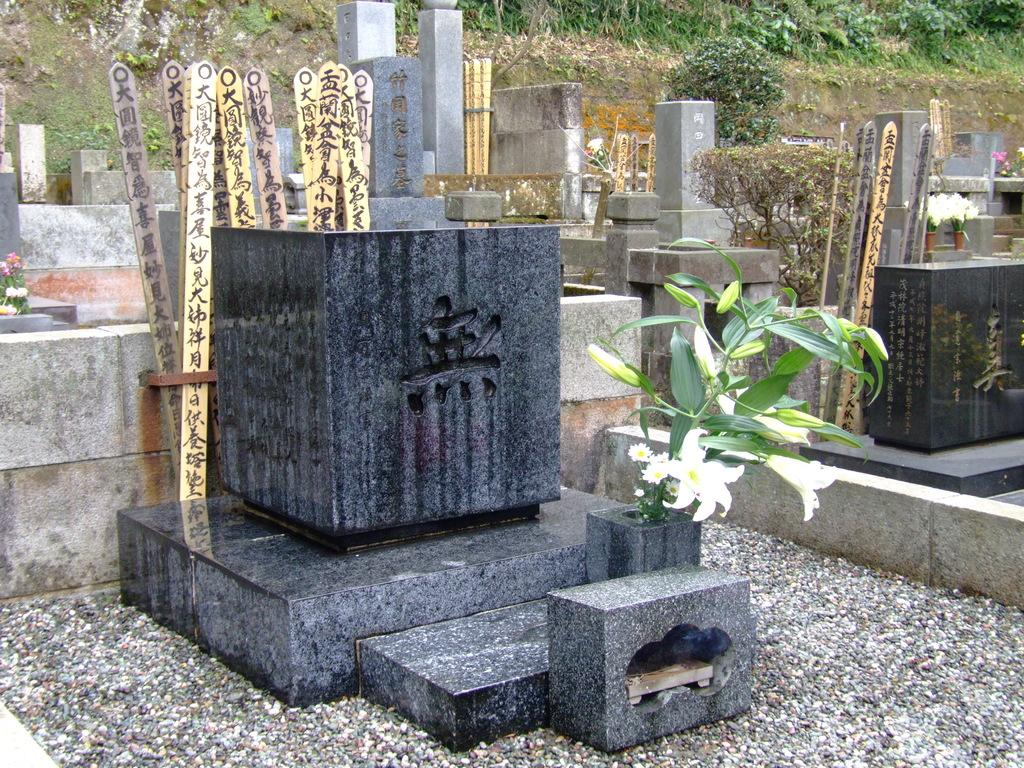What type of natural elements can be seen in the image? There are stones, a flower plant, and grass visible in the image. What is the flower plant placed in? The flower plant is placed in a planter. What object made of wood is present in the image? There is a wooden stick in the image. Where is the alley located in the image? There is no alley present in the image. What type of nest can be seen in the image? There is no nest present in the image. 